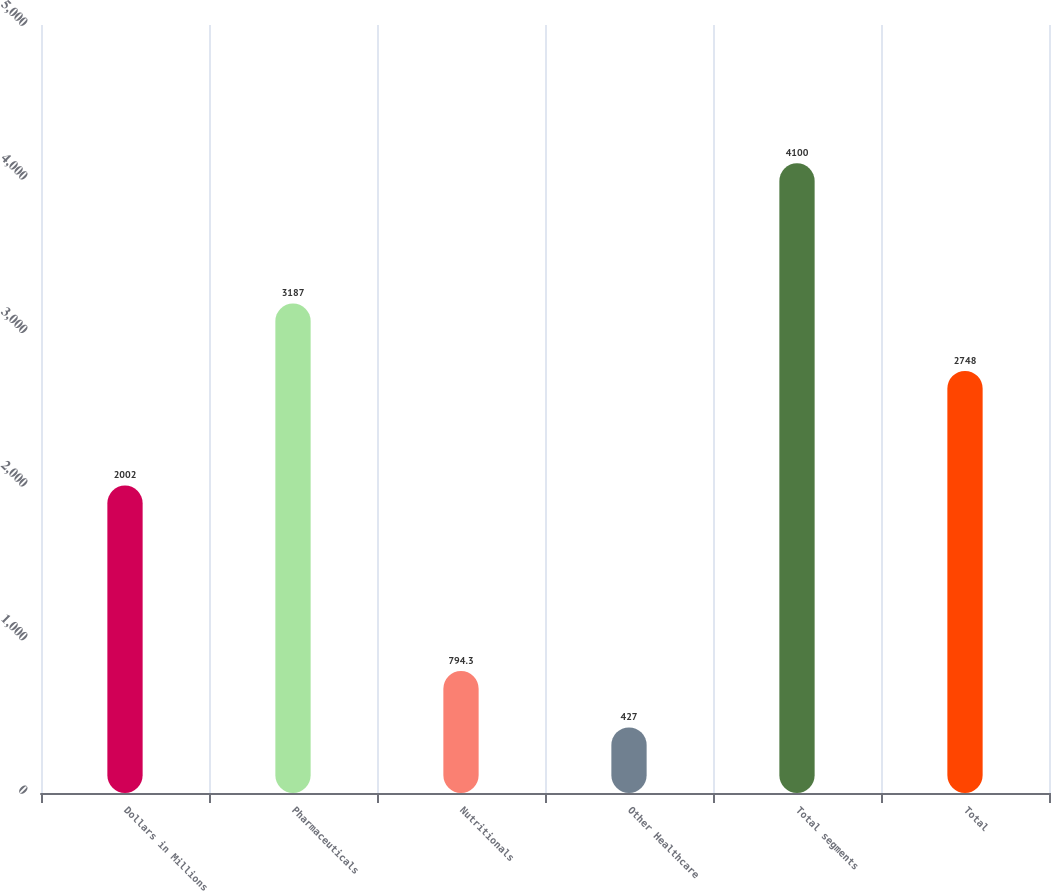Convert chart. <chart><loc_0><loc_0><loc_500><loc_500><bar_chart><fcel>Dollars in Millions<fcel>Pharmaceuticals<fcel>Nutritionals<fcel>Other Healthcare<fcel>Total segments<fcel>Total<nl><fcel>2002<fcel>3187<fcel>794.3<fcel>427<fcel>4100<fcel>2748<nl></chart> 